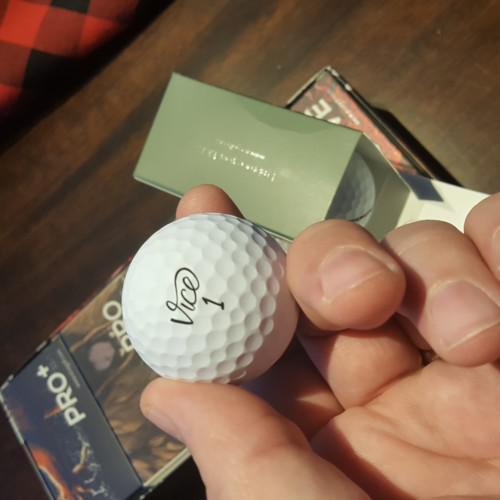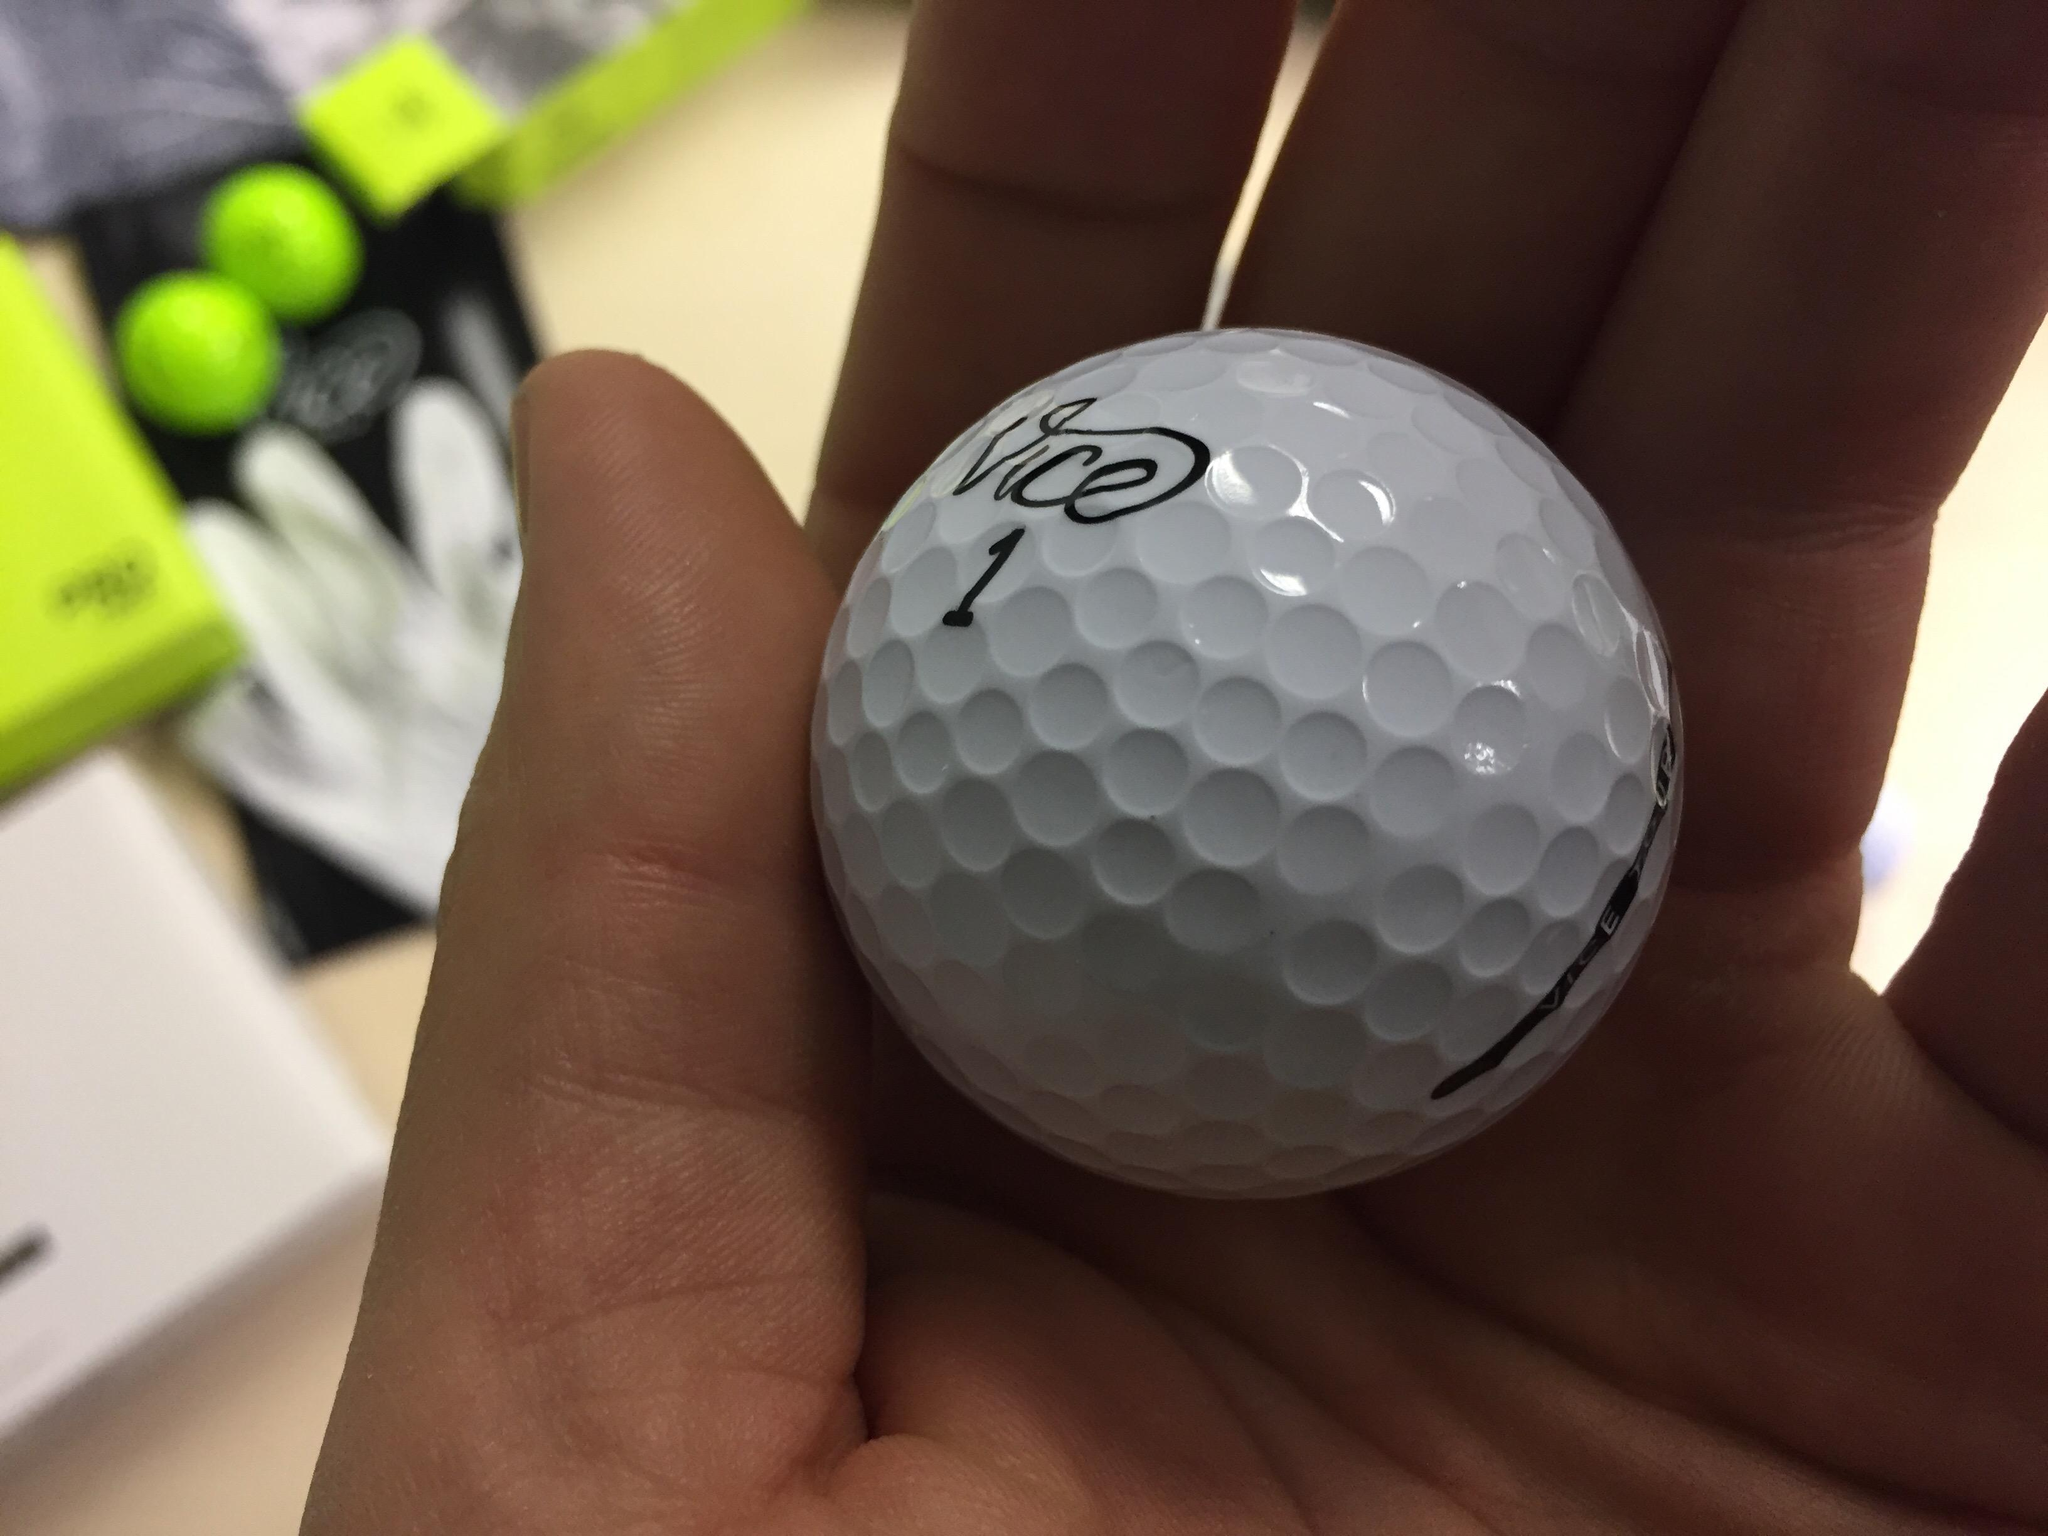The first image is the image on the left, the second image is the image on the right. Given the left and right images, does the statement "Both pictures contain what appear to be the same single golf ball." hold true? Answer yes or no. Yes. The first image is the image on the left, the second image is the image on the right. Evaluate the accuracy of this statement regarding the images: "There are both green and white golfballs.". Is it true? Answer yes or no. Yes. 